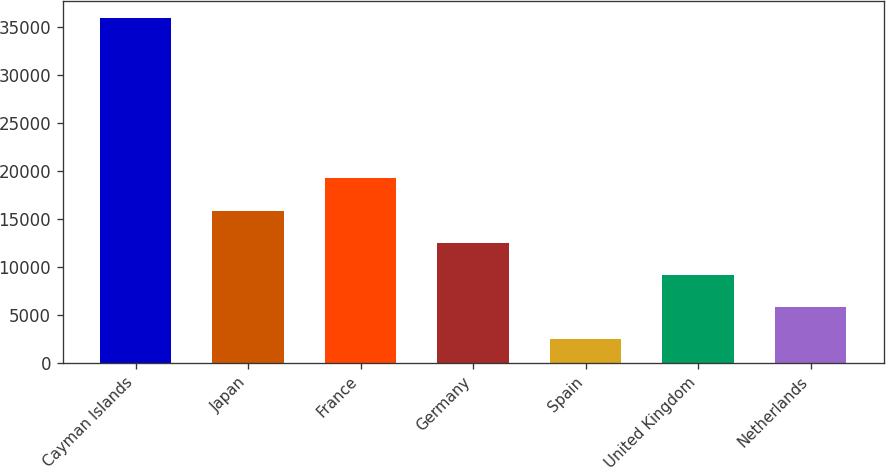Convert chart. <chart><loc_0><loc_0><loc_500><loc_500><bar_chart><fcel>Cayman Islands<fcel>Japan<fcel>France<fcel>Germany<fcel>Spain<fcel>United Kingdom<fcel>Netherlands<nl><fcel>35969<fcel>15882.2<fcel>19230<fcel>12534.4<fcel>2491<fcel>9186.6<fcel>5838.8<nl></chart> 